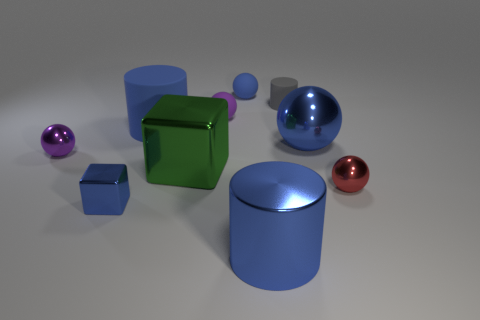How do the textures of the objects compare in this scene? The scene presents a variety of textures: the cylinders and spheres have smooth and reflective surfaces, highlighting their glossy appearance, whereas the cubes exhibit a more matte finish with less reflection, giving a softer visual effect. 